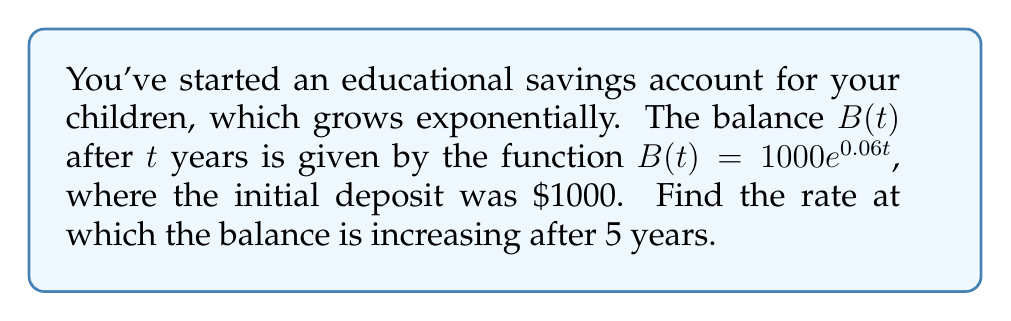Provide a solution to this math problem. To find the rate at which the balance is increasing after 5 years, we need to find the derivative of $B(t)$ and evaluate it at $t=5$. Here's how we do it step-by-step:

1) The given function is $B(t) = 1000e^{0.06t}$

2) To find the derivative, we use the chain rule:
   $$\frac{dB}{dt} = 1000 \cdot \frac{d}{dt}(e^{0.06t})$$

3) The derivative of $e^x$ is $e^x$, so:
   $$\frac{dB}{dt} = 1000 \cdot 0.06e^{0.06t}$$

4) Simplify:
   $$\frac{dB}{dt} = 60e^{0.06t}$$

5) Now, we evaluate this at $t=5$:
   $$\frac{dB}{dt}\bigg|_{t=5} = 60e^{0.06(5)} = 60e^{0.3}$$

6) Calculate:
   $$60e^{0.3} \approx 80.45$$

Therefore, after 5 years, the balance is increasing at a rate of approximately $80.45 per year.
Answer: $60e^{0.3} \approx 80.45$ dollars per year 